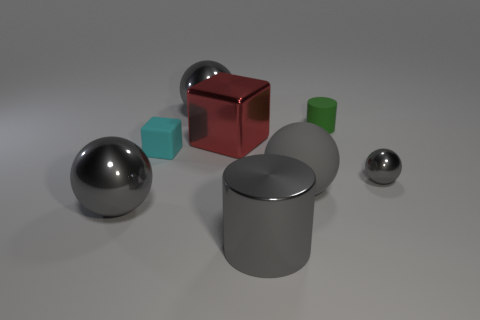What shape is the big matte object that is the same color as the large cylinder?
Your response must be concise. Sphere. Is there a matte sphere of the same color as the small metallic object?
Provide a short and direct response. Yes. What number of other things are there of the same size as the cyan cube?
Offer a terse response. 2. What material is the gray sphere on the left side of the large sphere behind the small matte object that is to the left of the large cylinder?
Provide a short and direct response. Metal. How many blocks are cyan matte things or tiny rubber objects?
Your answer should be compact. 1. Are there more rubber things that are left of the large red cube than small shiny objects in front of the gray metallic cylinder?
Offer a terse response. Yes. What number of big cubes are to the left of the large gray metallic ball that is in front of the red metallic cube?
Make the answer very short. 0. What number of objects are big matte balls or big metallic balls?
Your response must be concise. 3. Do the tiny cyan object and the gray rubber object have the same shape?
Your response must be concise. No. What is the material of the small cyan block?
Keep it short and to the point. Rubber. 